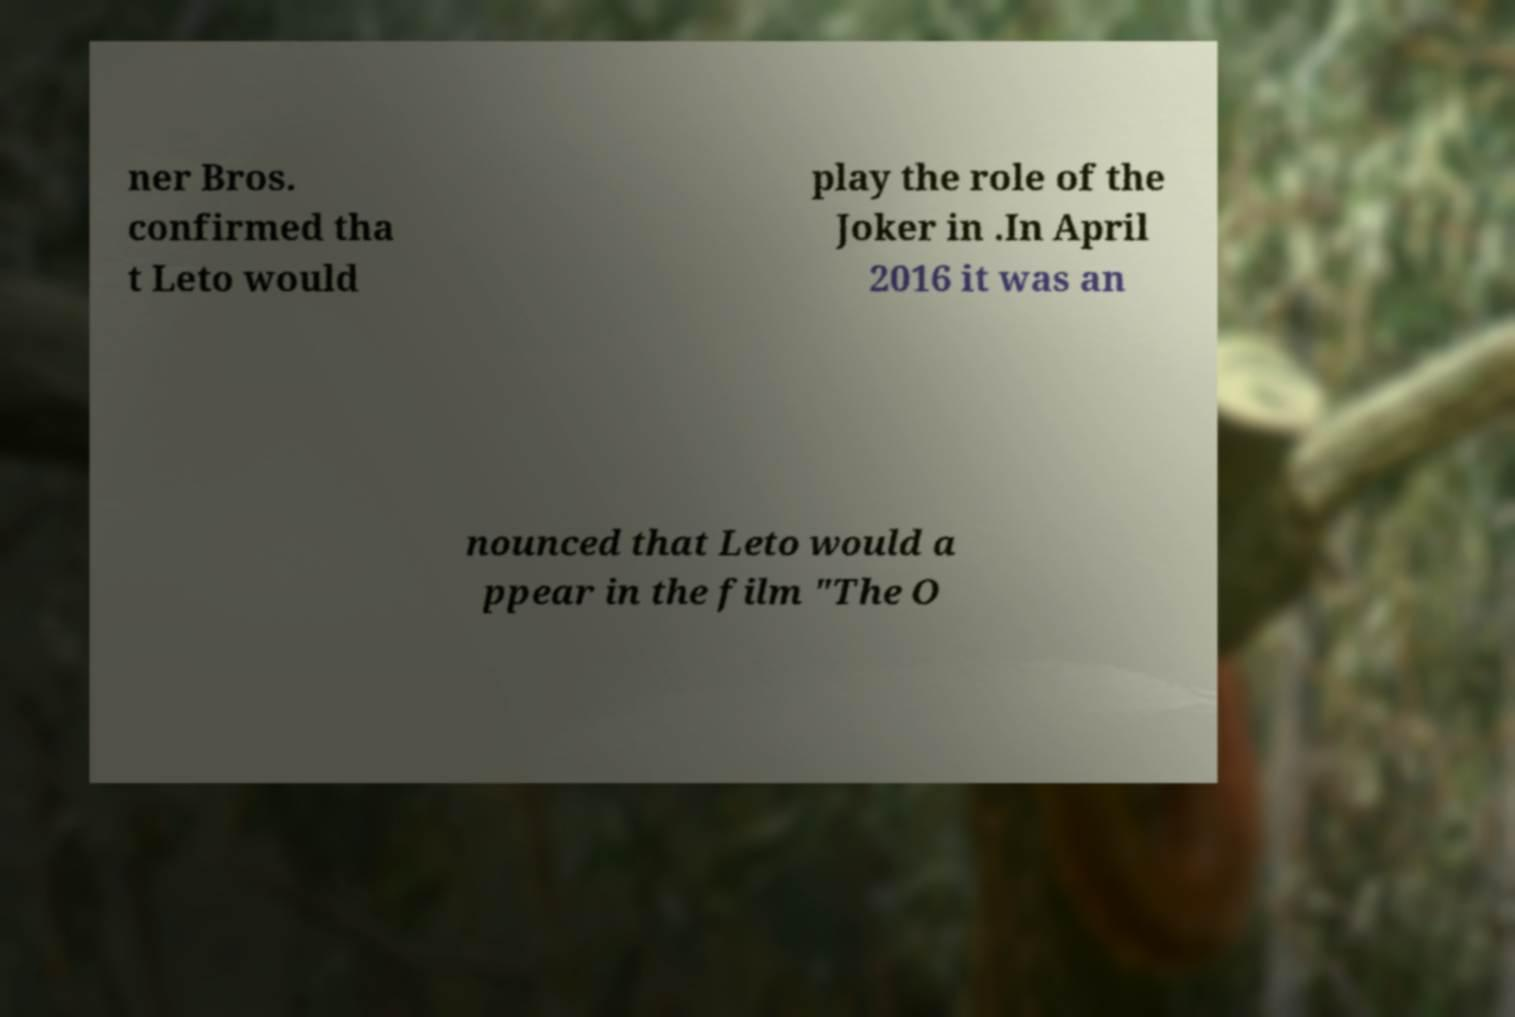Could you extract and type out the text from this image? ner Bros. confirmed tha t Leto would play the role of the Joker in .In April 2016 it was an nounced that Leto would a ppear in the film "The O 